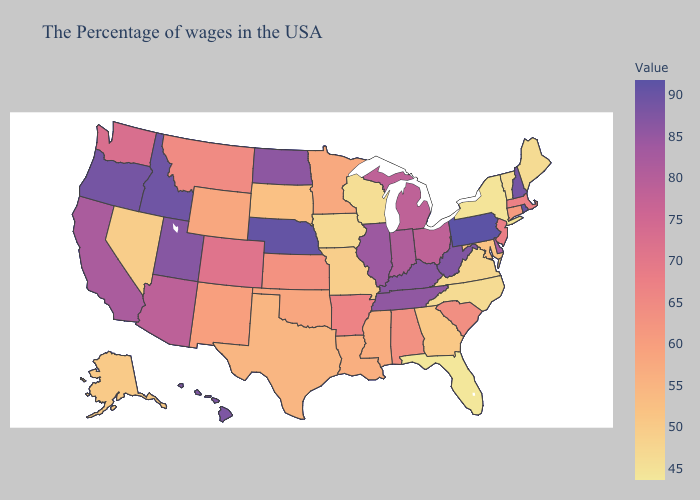Does Utah have the highest value in the USA?
Quick response, please. No. Does California have the highest value in the USA?
Write a very short answer. No. Does Utah have the highest value in the West?
Write a very short answer. No. Among the states that border Pennsylvania , does Delaware have the highest value?
Short answer required. No. Does Florida have the lowest value in the USA?
Short answer required. Yes. Does Pennsylvania have the highest value in the USA?
Keep it brief. Yes. Among the states that border Texas , which have the highest value?
Be succinct. Arkansas. 